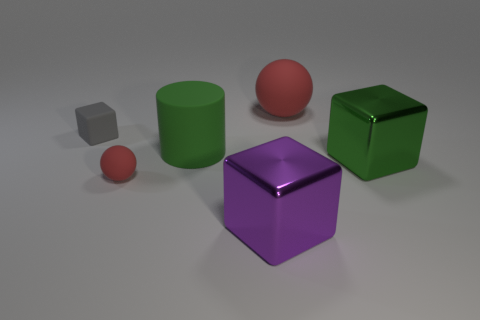Are there any pairs of objects that are exact color matches? Yes, there are two pairs of objects that have matching colors. The small ball and the larger ball share the same shade of red, and the purple cube in the center matches the smaller purple cube to its right in hue, though their surfaces might reflect light slightly differently due to size and angle differences, which can affect perception of color. 